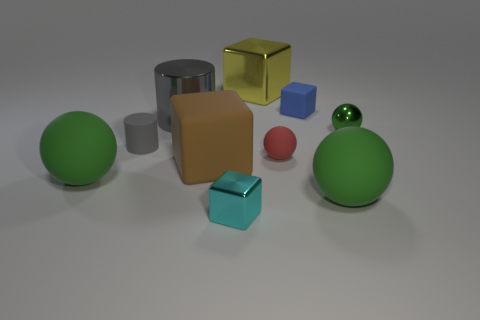What number of gray metal things are there?
Give a very brief answer. 1. How many big spheres have the same material as the large gray object?
Offer a very short reply. 0. What is the size of the shiny thing that is the same shape as the small gray rubber object?
Offer a very short reply. Large. What material is the yellow thing?
Offer a very short reply. Metal. What material is the tiny thing that is right of the large green rubber thing in front of the rubber ball left of the brown matte block made of?
Offer a terse response. Metal. Are there any other things that have the same shape as the tiny blue object?
Your answer should be compact. Yes. What color is the other large thing that is the same shape as the brown thing?
Make the answer very short. Yellow. There is a tiny shiny object that is in front of the red matte object; does it have the same color as the matte sphere behind the large rubber cube?
Provide a succinct answer. No. Is the number of tiny matte cylinders that are behind the tiny gray matte cylinder greater than the number of small matte blocks?
Keep it short and to the point. No. What number of other things are the same size as the yellow metal object?
Your answer should be compact. 4. 